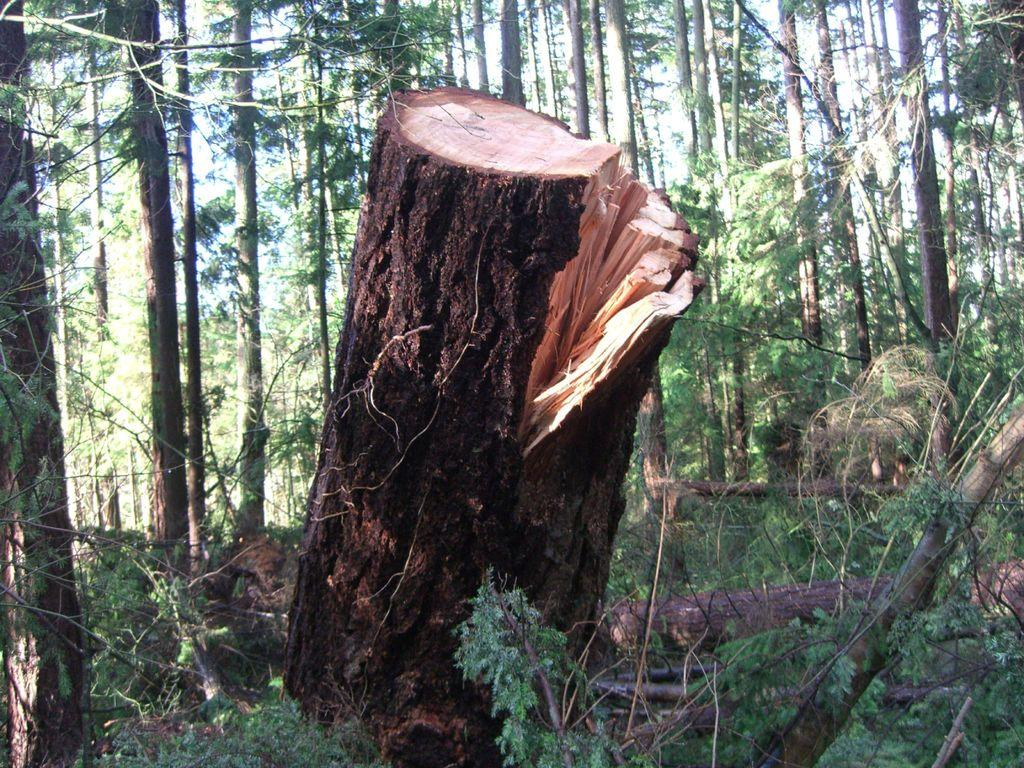What is the main subject of the image? The main subject of the image is a tree trunk. Are there any other plants visible in the image? Yes, there are plants in the image. What can be seen in the background of the image? There are trees visible in the background of the image. What type of paper is being used to weigh down the tree trunk in the image? There is no paper or any indication of weighing down the tree trunk in the image. 